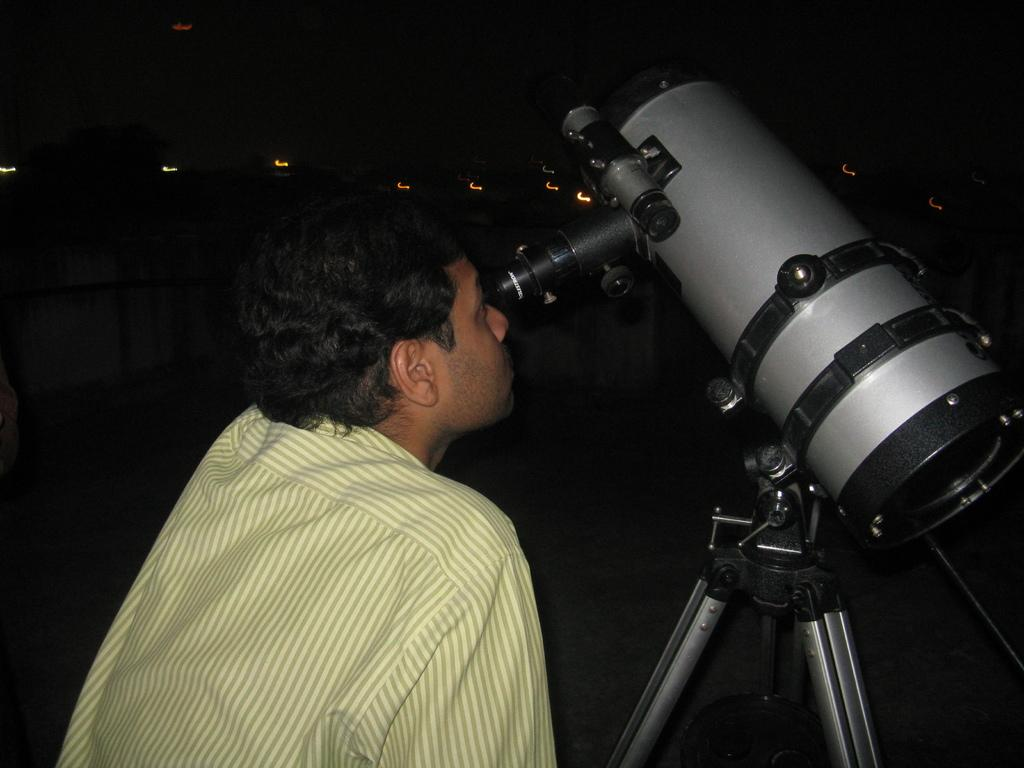What is the man in the image doing? The man is using a tripod in the image. What is on the tripod that the man is using? A telescope is present on the tripod. What color is the shirt the man is wearing? The man is wearing a yellow shirt. How would you describe the lighting in the image? The background of the image appears to be dark. What type of liquid is leaking from the hole in the telescope in the image? There is no hole or liquid present in the telescope in the image. 